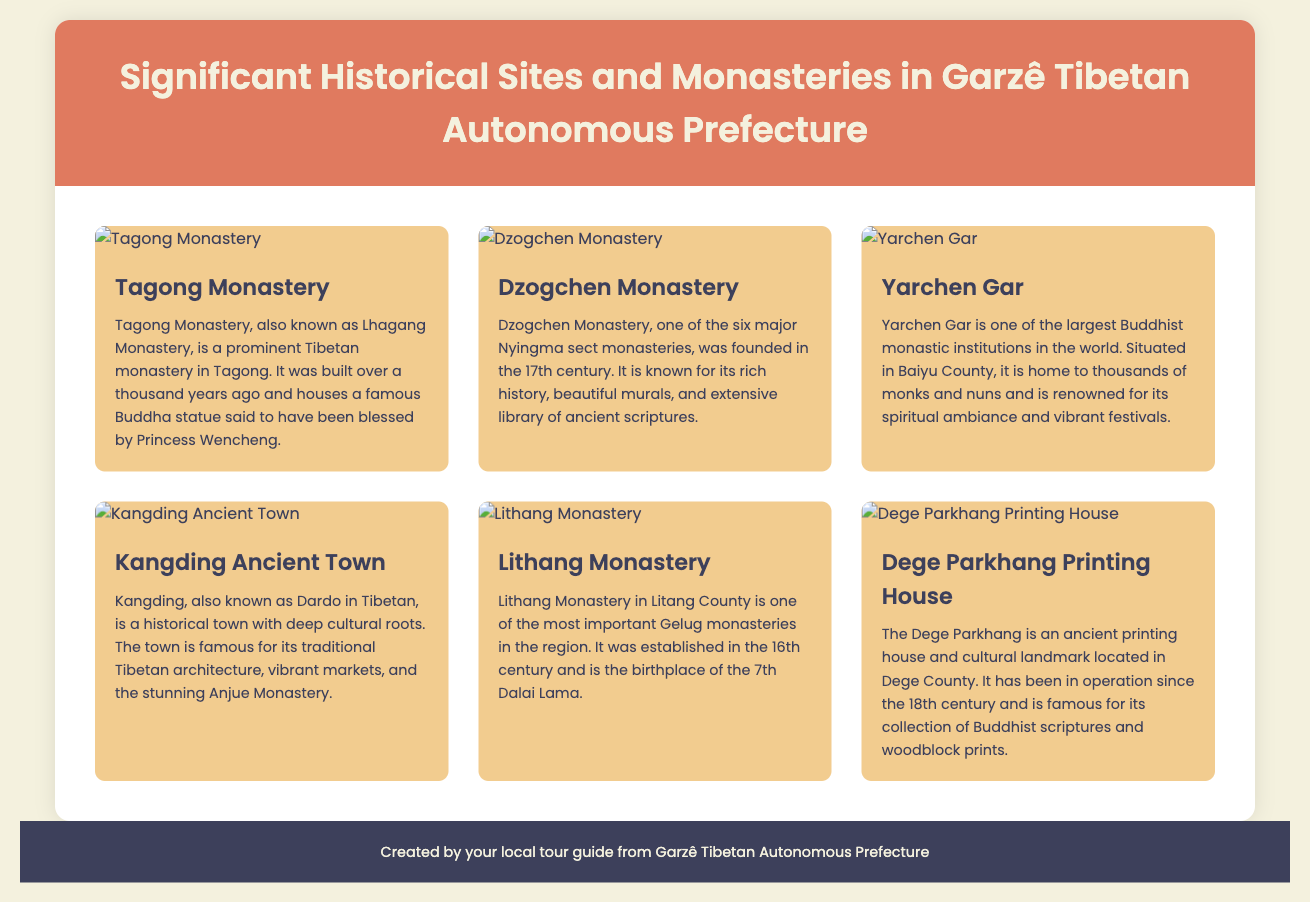What is the oldest monastery mentioned? The oldest monastery in the document is Tagong Monastery, built over a thousand years ago.
Answer: Tagong Monastery How many major Nyingma sect monasteries are there? Dzogchen Monastery is mentioned as one of the six major Nyingma sect monasteries.
Answer: Six Where is Yarchen Gar located? Yarchen Gar is located in Baiyu County, as stated in the document.
Answer: Baiyu County What is the significance of Lithang Monastery? Lithang Monastery is the birthplace of the 7th Dalai Lama and was established in the 16th century.
Answer: Birthplace of the 7th Dalai Lama Which site is known for its ancient printing house? The site known for its ancient printing house is Dege Parkhang.
Answer: Dege Parkhang What type of architecture is Kangding Ancient Town known for? Kangding Ancient Town is famous for its traditional Tibetan architecture.
Answer: Traditional Tibetan architecture 